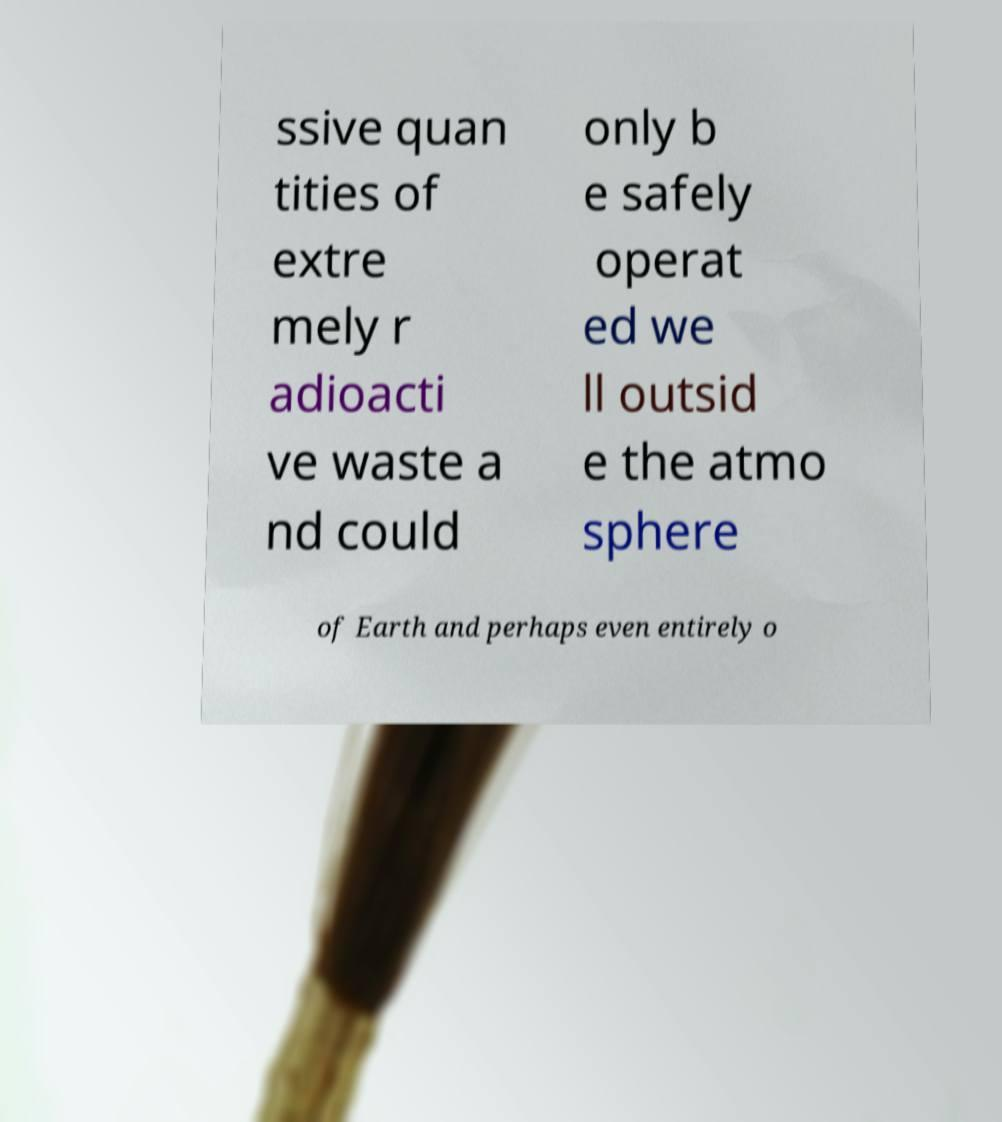For documentation purposes, I need the text within this image transcribed. Could you provide that? ssive quan tities of extre mely r adioacti ve waste a nd could only b e safely operat ed we ll outsid e the atmo sphere of Earth and perhaps even entirely o 